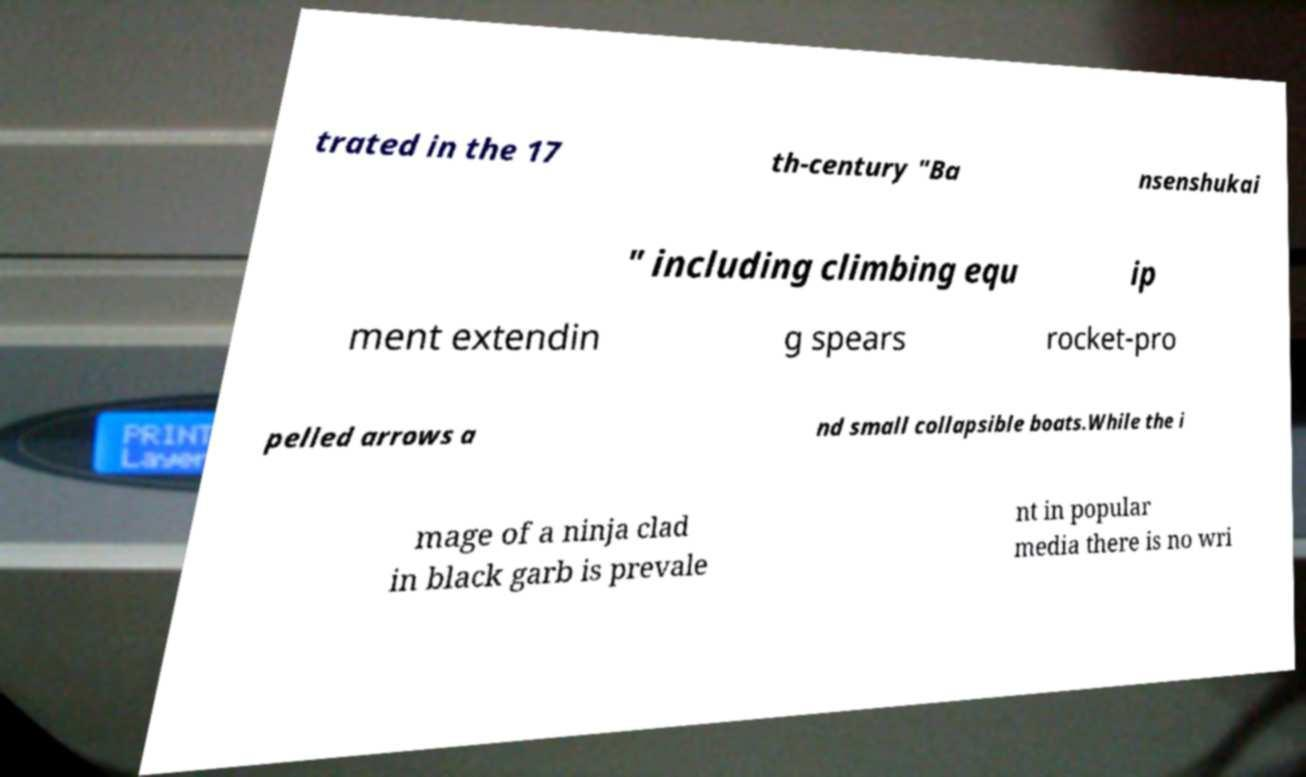Please identify and transcribe the text found in this image. trated in the 17 th-century "Ba nsenshukai " including climbing equ ip ment extendin g spears rocket-pro pelled arrows a nd small collapsible boats.While the i mage of a ninja clad in black garb is prevale nt in popular media there is no wri 